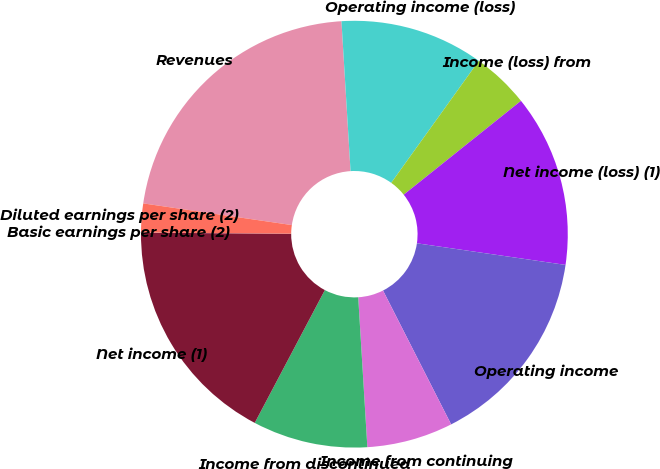Convert chart to OTSL. <chart><loc_0><loc_0><loc_500><loc_500><pie_chart><fcel>Revenues<fcel>Operating income (loss)<fcel>Income (loss) from<fcel>Net income (loss) (1)<fcel>Operating income<fcel>Income from continuing<fcel>Income from discontinued<fcel>Net income (1)<fcel>Basic earnings per share (2)<fcel>Diluted earnings per share (2)<nl><fcel>21.73%<fcel>10.87%<fcel>4.35%<fcel>13.04%<fcel>15.21%<fcel>6.52%<fcel>8.7%<fcel>17.38%<fcel>0.01%<fcel>2.18%<nl></chart> 